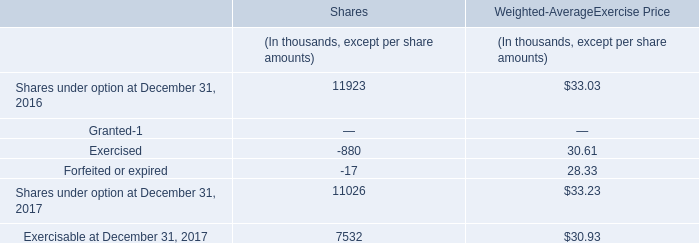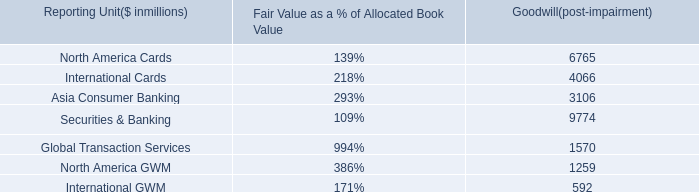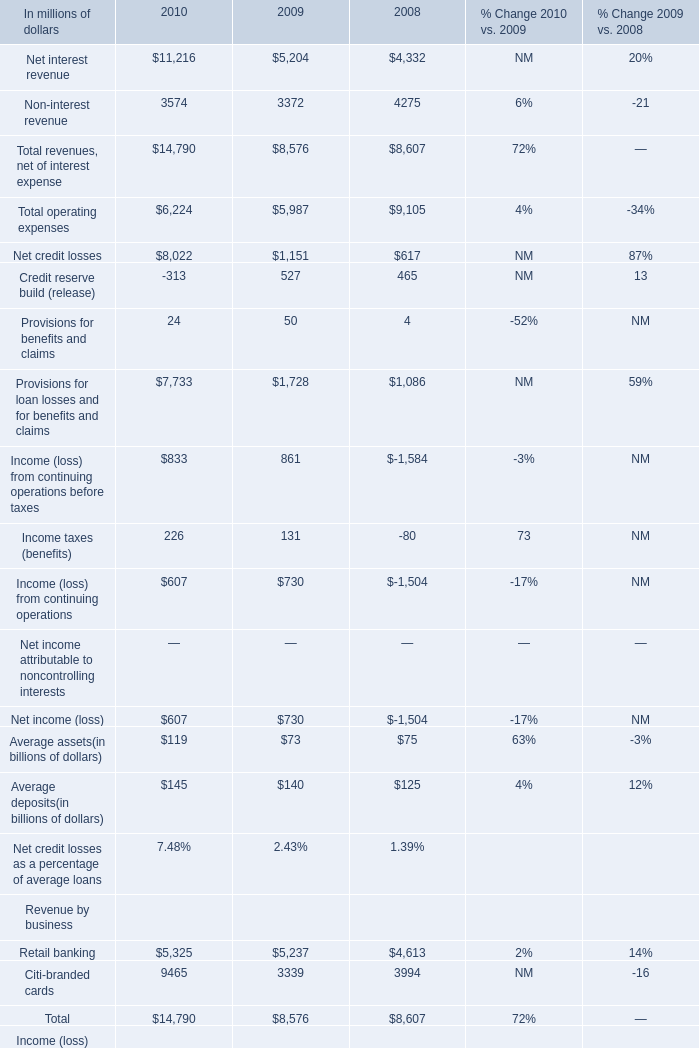If Net interest revenue develops with the same growth rate in 2010, what will it reach in 2011? (in million) 
Computations: (11216 * (1 + ((11216 - 5204) / 5204)))
Answer: 24173.45427. 